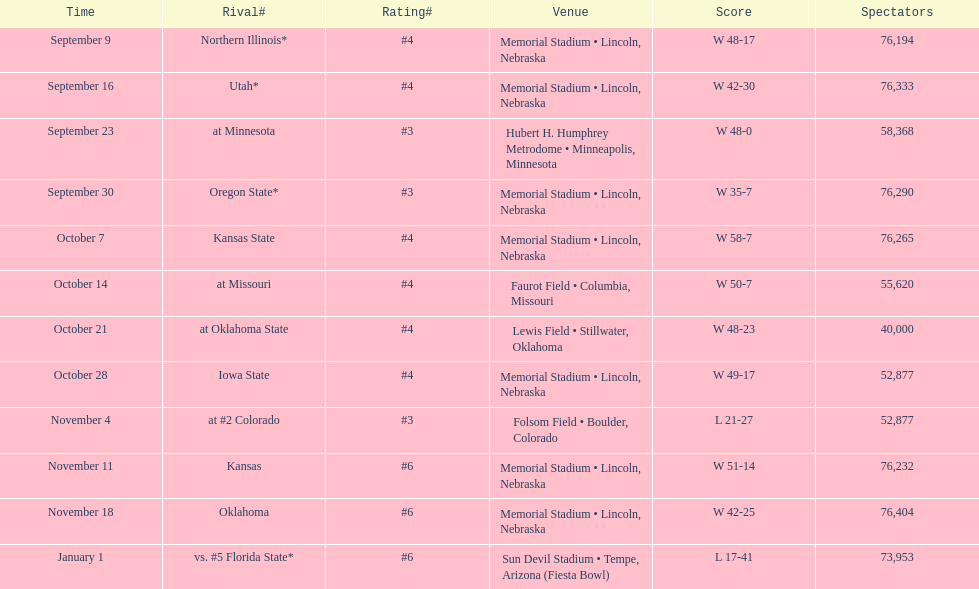Which month has the lowest frequency on this chart? January. 